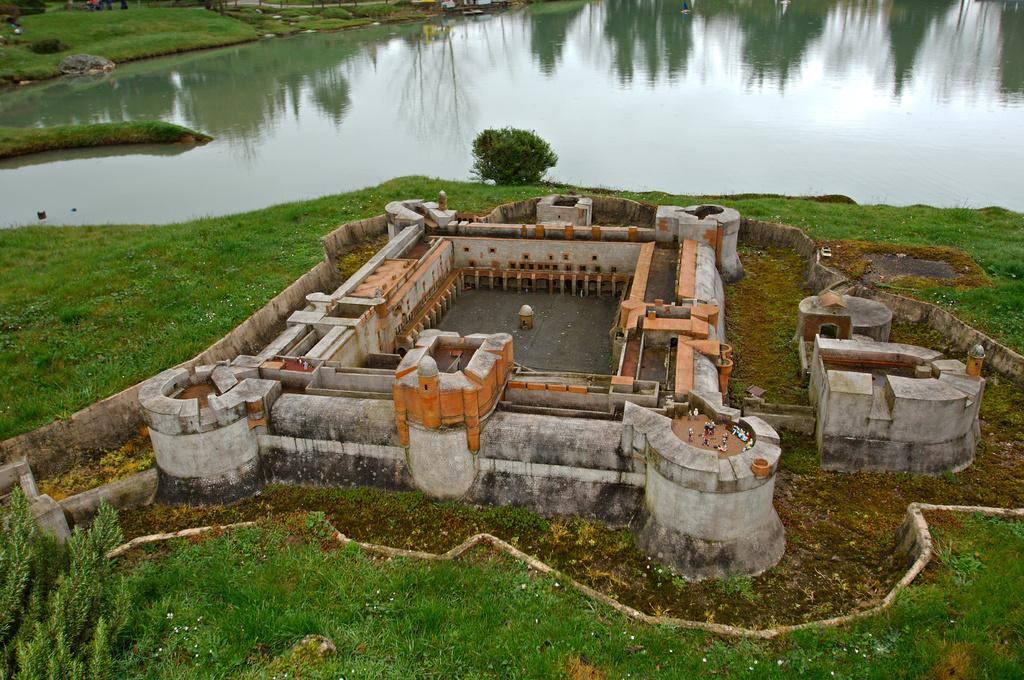What is the main subject of the picture? The main subject of the picture is a castle construction. What type of terrain is visible at the bottom of the picture? There is green grass at the bottom of the picture. What body of water can be seen in the picture? There is a water pool in the picture. What type of vegetation is present at the top of the picture? There are trees at the top of the picture. What type of cracker is being used to build the castle in the picture? There is no cracker present in the picture; the castle construction is not made of crackers. 